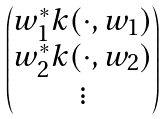Convert formula to latex. <formula><loc_0><loc_0><loc_500><loc_500>\begin{pmatrix} w _ { 1 } ^ { * } k ( \cdot , w _ { 1 } ) \\ w _ { 2 } ^ { * } k ( \cdot , w _ { 2 } ) \\ \vdots \end{pmatrix}</formula> 